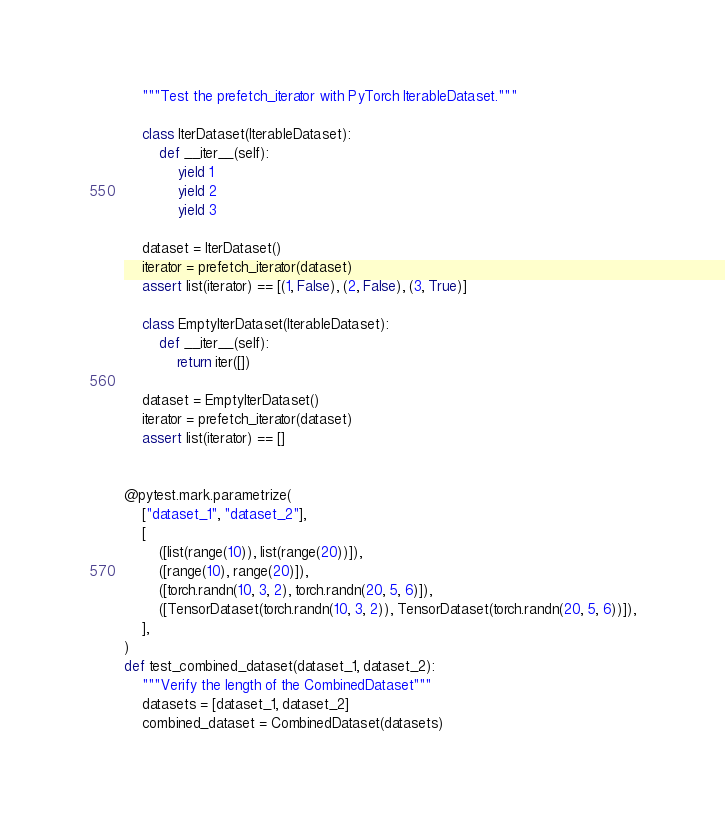<code> <loc_0><loc_0><loc_500><loc_500><_Python_>    """Test the prefetch_iterator with PyTorch IterableDataset."""

    class IterDataset(IterableDataset):
        def __iter__(self):
            yield 1
            yield 2
            yield 3

    dataset = IterDataset()
    iterator = prefetch_iterator(dataset)
    assert list(iterator) == [(1, False), (2, False), (3, True)]

    class EmptyIterDataset(IterableDataset):
        def __iter__(self):
            return iter([])

    dataset = EmptyIterDataset()
    iterator = prefetch_iterator(dataset)
    assert list(iterator) == []


@pytest.mark.parametrize(
    ["dataset_1", "dataset_2"],
    [
        ([list(range(10)), list(range(20))]),
        ([range(10), range(20)]),
        ([torch.randn(10, 3, 2), torch.randn(20, 5, 6)]),
        ([TensorDataset(torch.randn(10, 3, 2)), TensorDataset(torch.randn(20, 5, 6))]),
    ],
)
def test_combined_dataset(dataset_1, dataset_2):
    """Verify the length of the CombinedDataset"""
    datasets = [dataset_1, dataset_2]
    combined_dataset = CombinedDataset(datasets)
</code> 